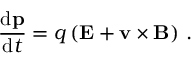Convert formula to latex. <formula><loc_0><loc_0><loc_500><loc_500>{ \frac { d p } { d t } } = q \left ( E + v \times B \right ) \, .</formula> 